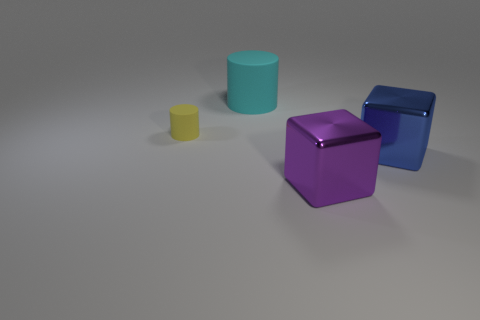What size is the block that is behind the large purple thing?
Provide a succinct answer. Large. What shape is the large metal thing left of the metal cube that is on the right side of the large shiny object in front of the large blue metal block?
Your answer should be compact. Cube. What shape is the object that is both left of the purple metallic cube and in front of the big cylinder?
Your answer should be compact. Cylinder. Is there a cyan object that has the same size as the purple shiny cube?
Ensure brevity in your answer.  Yes. There is a object on the left side of the large cyan cylinder; is its shape the same as the big purple metallic object?
Offer a very short reply. No. Do the yellow thing and the purple object have the same shape?
Offer a very short reply. No. Is there another purple thing that has the same shape as the purple object?
Ensure brevity in your answer.  No. The thing that is on the left side of the large thing behind the blue block is what shape?
Offer a terse response. Cylinder. There is a cube in front of the large blue metallic thing; what color is it?
Your answer should be compact. Purple. There is a yellow object that is made of the same material as the big cyan thing; what size is it?
Make the answer very short. Small. 